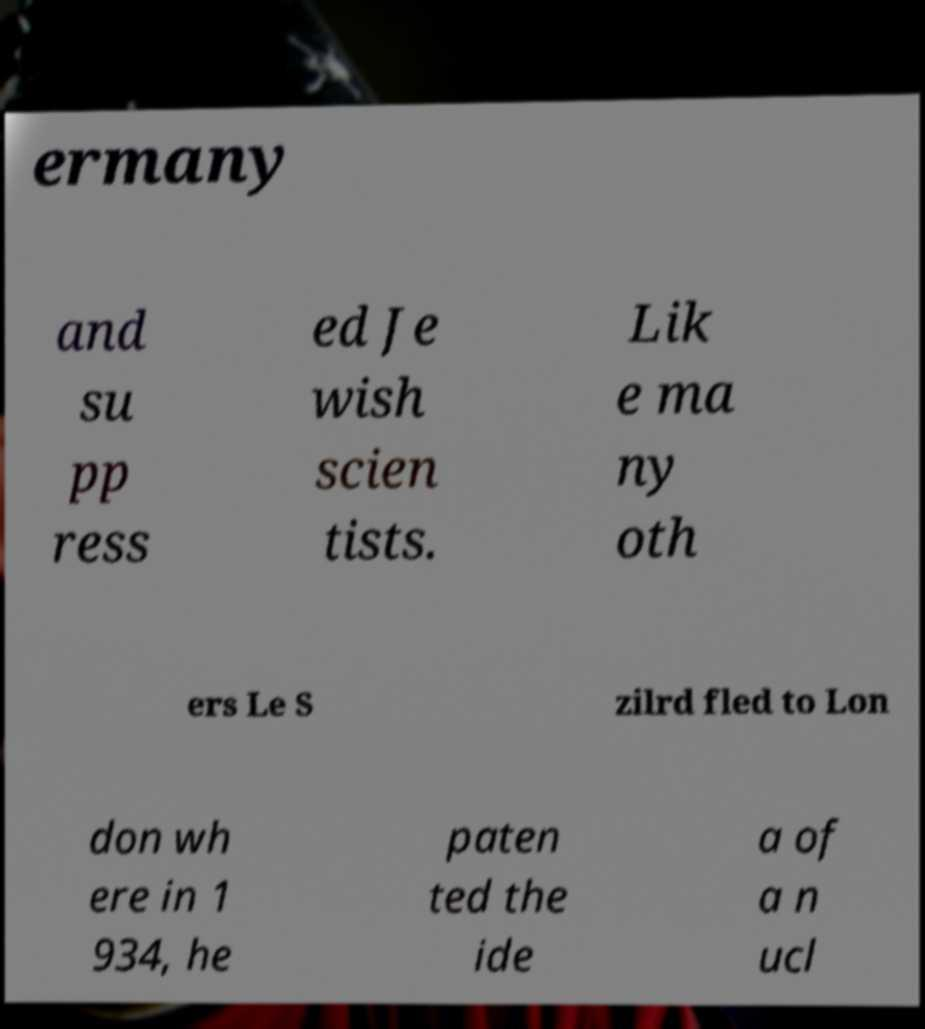Could you assist in decoding the text presented in this image and type it out clearly? ermany and su pp ress ed Je wish scien tists. Lik e ma ny oth ers Le S zilrd fled to Lon don wh ere in 1 934, he paten ted the ide a of a n ucl 